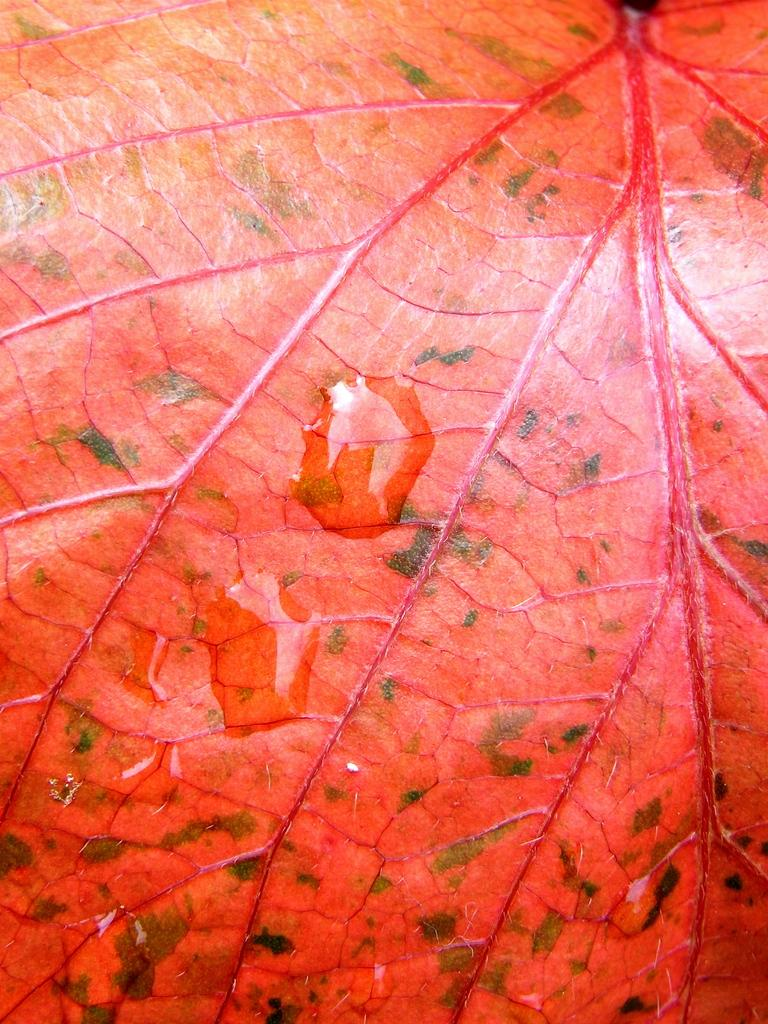What is the main subject of the image? The main subject of the image is a leaf. Can you describe the leaf in the image? The leaf has water droplets on it. What type of store can be seen in the background of the image? There is no store present in the image; it only features a leaf with water droplets. 